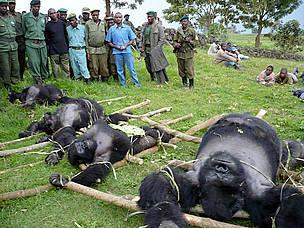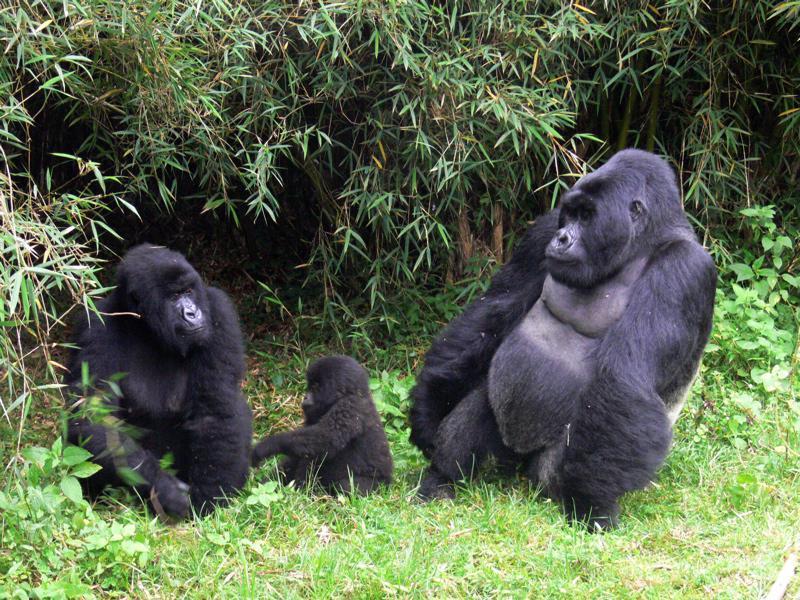The first image is the image on the left, the second image is the image on the right. Examine the images to the left and right. Is the description "In one of the pictures, a baby gorilla is near an adult gorilla." accurate? Answer yes or no. Yes. The first image is the image on the left, the second image is the image on the right. For the images displayed, is the sentence "Each image contains the same number of gorillas." factually correct? Answer yes or no. No. 